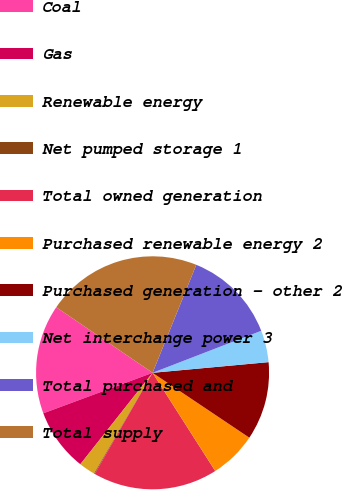Convert chart to OTSL. <chart><loc_0><loc_0><loc_500><loc_500><pie_chart><fcel>Coal<fcel>Gas<fcel>Renewable energy<fcel>Net pumped storage 1<fcel>Total owned generation<fcel>Purchased renewable energy 2<fcel>Purchased generation - other 2<fcel>Net interchange power 3<fcel>Total purchased and<fcel>Total supply<nl><fcel>15.16%<fcel>8.71%<fcel>2.26%<fcel>0.11%<fcel>17.31%<fcel>6.56%<fcel>10.86%<fcel>4.41%<fcel>13.01%<fcel>21.61%<nl></chart> 